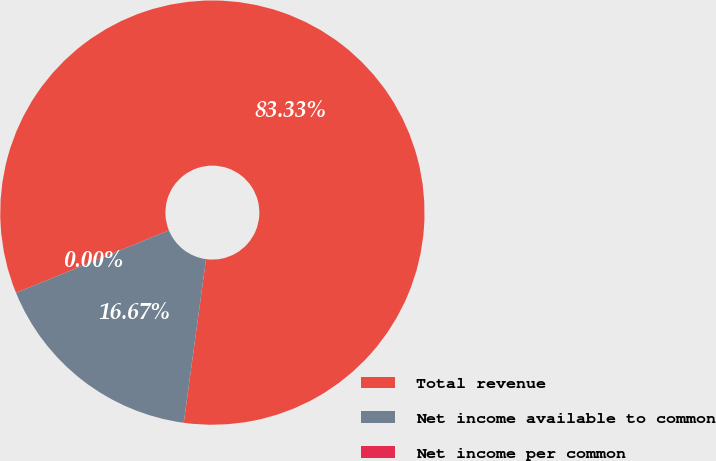Convert chart to OTSL. <chart><loc_0><loc_0><loc_500><loc_500><pie_chart><fcel>Total revenue<fcel>Net income available to common<fcel>Net income per common<nl><fcel>83.33%<fcel>16.67%<fcel>0.0%<nl></chart> 